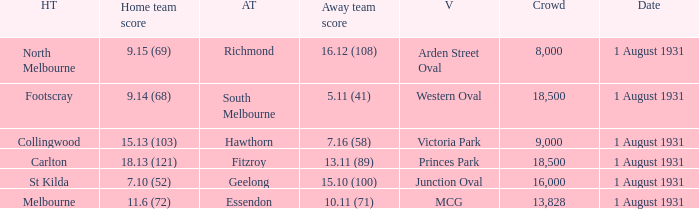What is the home team at the venue mcg? Melbourne. 